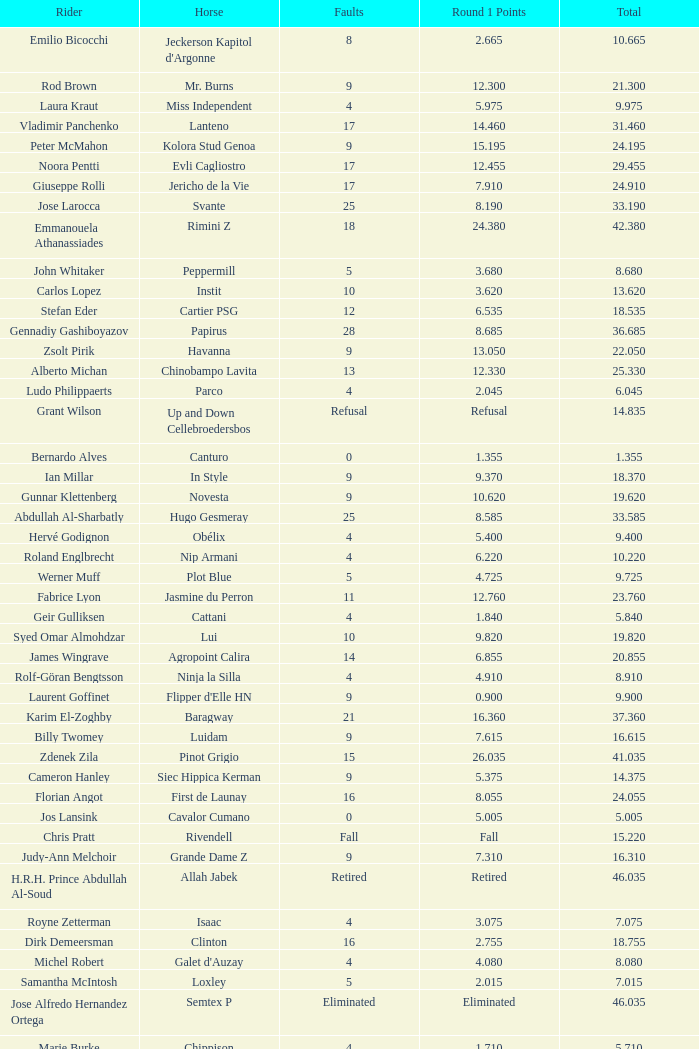Tell me the rider with 18.185 points round 1 Veronika Macanova. 